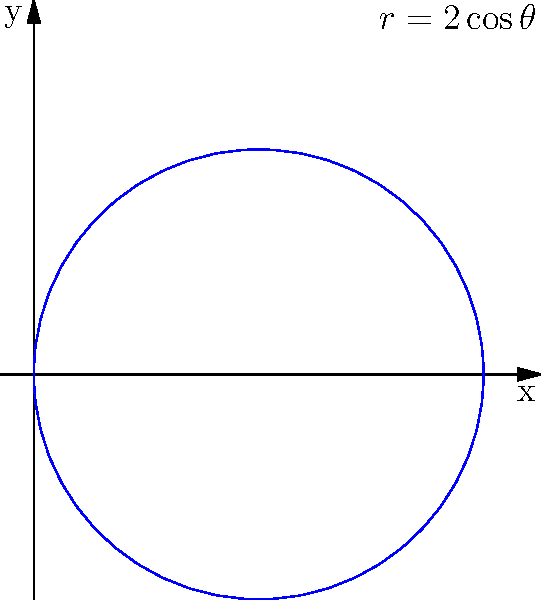Given the polar equation $r = 2\cos\theta$, what is the Cartesian equation of the resulting shape, and what type of conic section does it represent? To convert the polar equation $r = 2\cos\theta$ to Cartesian coordinates, we'll follow these steps:

1) Recall the conversion formulas:
   $x = r\cos\theta$
   $y = r\sin\theta$

2) Substitute $r = 2\cos\theta$ into these formulas:
   $x = 2\cos^2\theta$
   $y = 2\cos\theta\sin\theta$

3) Use the identity $\cos^2\theta = \frac{1 + \cos(2\theta)}{2}$:
   $x = 1 + \cos(2\theta)$

4) Use the identity $2\sin\theta\cos\theta = \sin(2\theta)$:
   $y = \sin(2\theta)$

5) Square both equations:
   $x^2 = 1 + 2\cos(2\theta) + \cos^2(2\theta)$
   $y^2 = \sin^2(2\theta)$

6) Add these equations:
   $x^2 + y^2 = 1 + 2\cos(2\theta) + \cos^2(2\theta) + \sin^2(2\theta)$

7) Use the identity $\cos^2(2\theta) + \sin^2(2\theta) = 1$:
   $x^2 + y^2 = 2 + 2\cos(2\theta)$

8) Rearrange:
   $x^2 + y^2 - 2 = 2\cos(2\theta)$

9) Recall from step 3 that $\cos(2\theta) = x - 1$:
   $x^2 + y^2 - 2 = 2(x - 1)$

10) Simplify:
    $x^2 + y^2 - 2x = 0$

11) Complete the square for x:
    $(x^2 - 2x + 1) + y^2 - 1 = 0$
    $(x - 1)^2 + y^2 = 1$

This is the standard form equation of a circle with center (1,0) and radius 1.
Answer: $(x - 1)^2 + y^2 = 1$; Circle 